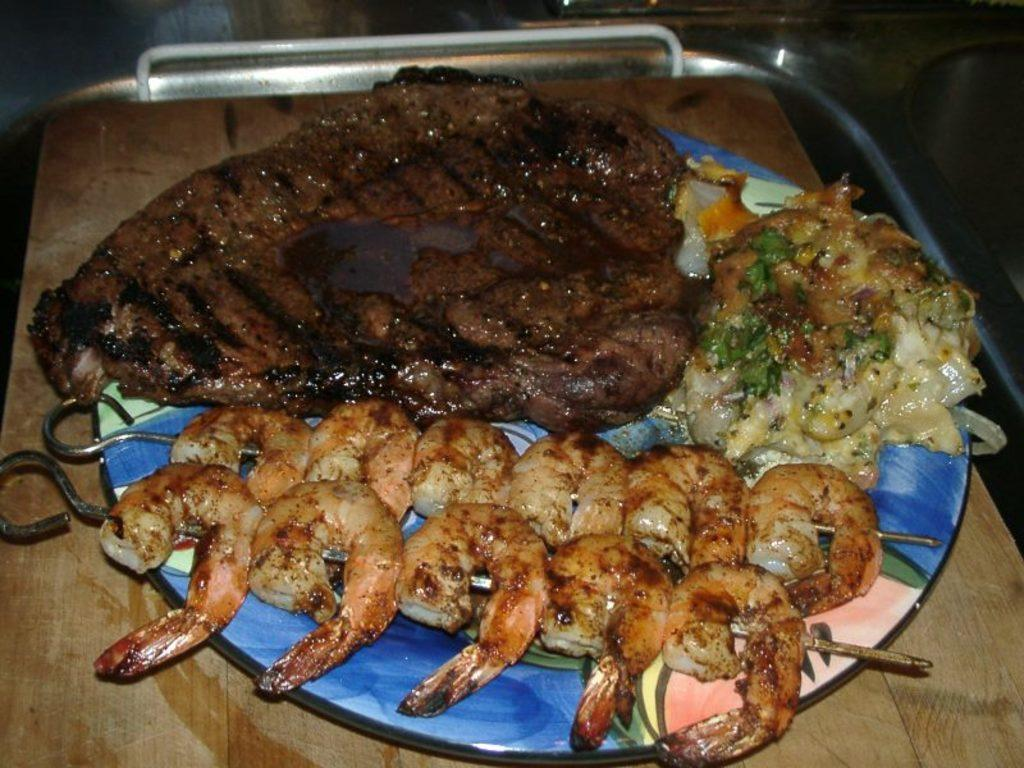What objects are present in the image that can be used for cooking or serving food? There are skewers in the image. What type of food items can be seen in the image? There are food items in the image. How are the food items arranged in the image? The food items are on a plate. What is the surface on which the plate is placed? The plate is placed on a wooden surface. How many chickens are visible in the image? There are no chickens present in the image. What type of holiday is being celebrated in the image? There is no indication of a holiday being celebrated in the image. 